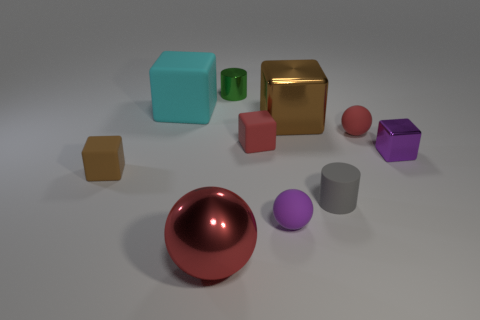The other small ball that is the same material as the small red ball is what color?
Make the answer very short. Purple. There is a large metallic sphere; is its color the same as the cylinder behind the tiny red matte sphere?
Your answer should be compact. No. There is a small sphere on the left side of the red matte object that is right of the small gray cylinder; is there a gray matte thing in front of it?
Keep it short and to the point. No. There is a brown thing that is made of the same material as the purple cube; what shape is it?
Keep it short and to the point. Cube. Are there any other things that have the same shape as the small green metal thing?
Your answer should be compact. Yes. The large red object has what shape?
Offer a very short reply. Sphere. Do the tiny red rubber object right of the tiny gray rubber cylinder and the big red metal object have the same shape?
Give a very brief answer. Yes. Are there more small matte cubes that are to the right of the small red matte cube than big red metal things that are behind the cyan cube?
Make the answer very short. No. What number of other objects are there of the same size as the gray matte cylinder?
Offer a terse response. 6. There is a tiny brown matte object; does it have the same shape as the big thing in front of the small red matte block?
Keep it short and to the point. No. 